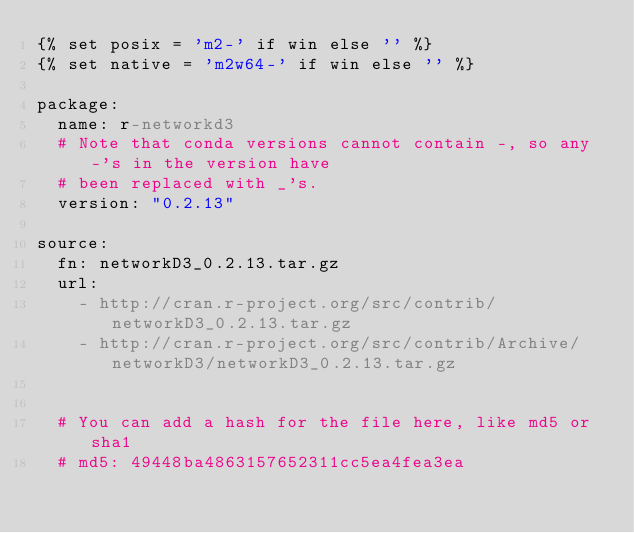Convert code to text. <code><loc_0><loc_0><loc_500><loc_500><_YAML_>{% set posix = 'm2-' if win else '' %}
{% set native = 'm2w64-' if win else '' %}

package:
  name: r-networkd3
  # Note that conda versions cannot contain -, so any -'s in the version have
  # been replaced with _'s.
  version: "0.2.13"

source:
  fn: networkD3_0.2.13.tar.gz
  url:
    - http://cran.r-project.org/src/contrib/networkD3_0.2.13.tar.gz
    - http://cran.r-project.org/src/contrib/Archive/networkD3/networkD3_0.2.13.tar.gz


  # You can add a hash for the file here, like md5 or sha1
  # md5: 49448ba4863157652311cc5ea4fea3ea</code> 